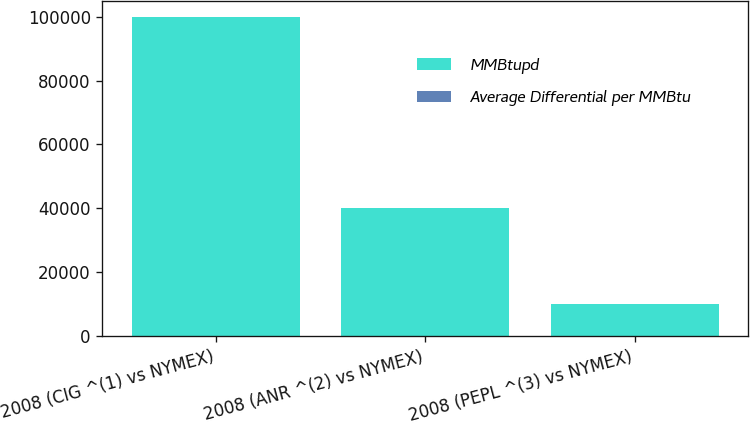Convert chart to OTSL. <chart><loc_0><loc_0><loc_500><loc_500><stacked_bar_chart><ecel><fcel>2008 (CIG ^(1) vs NYMEX)<fcel>2008 (ANR ^(2) vs NYMEX)<fcel>2008 (PEPL ^(3) vs NYMEX)<nl><fcel>MMBtupd<fcel>100000<fcel>40000<fcel>10000<nl><fcel>Average Differential per MMBtu<fcel>1.66<fcel>1.01<fcel>0.98<nl></chart> 